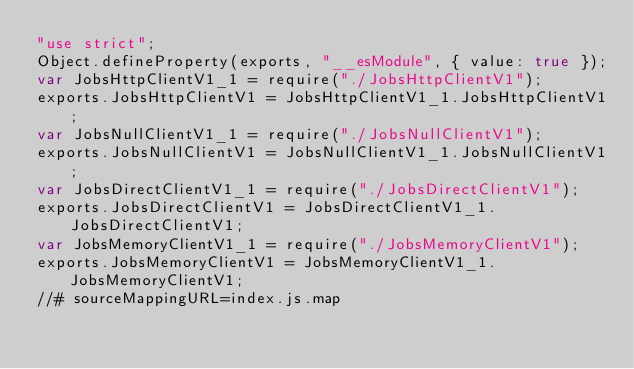Convert code to text. <code><loc_0><loc_0><loc_500><loc_500><_JavaScript_>"use strict";
Object.defineProperty(exports, "__esModule", { value: true });
var JobsHttpClientV1_1 = require("./JobsHttpClientV1");
exports.JobsHttpClientV1 = JobsHttpClientV1_1.JobsHttpClientV1;
var JobsNullClientV1_1 = require("./JobsNullClientV1");
exports.JobsNullClientV1 = JobsNullClientV1_1.JobsNullClientV1;
var JobsDirectClientV1_1 = require("./JobsDirectClientV1");
exports.JobsDirectClientV1 = JobsDirectClientV1_1.JobsDirectClientV1;
var JobsMemoryClientV1_1 = require("./JobsMemoryClientV1");
exports.JobsMemoryClientV1 = JobsMemoryClientV1_1.JobsMemoryClientV1;
//# sourceMappingURL=index.js.map</code> 